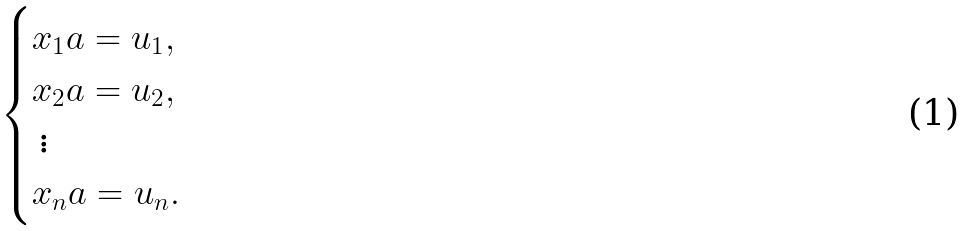<formula> <loc_0><loc_0><loc_500><loc_500>\begin{cases} x _ { 1 } a = u _ { 1 } , \\ x _ { 2 } a = u _ { 2 } , \\ \, \vdots \\ x _ { n } a = u _ { n } . \end{cases}</formula> 